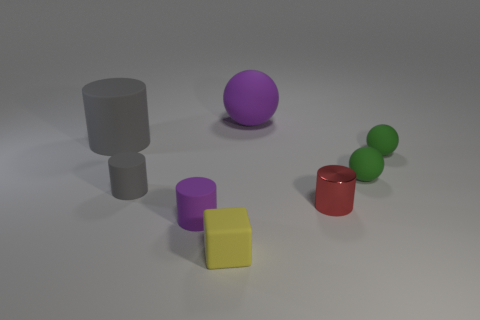Subtract all green spheres. How many were subtracted if there are1green spheres left? 1 Add 1 big blue rubber blocks. How many objects exist? 9 Subtract all cubes. How many objects are left? 7 Subtract 0 brown cubes. How many objects are left? 8 Subtract all yellow metallic balls. Subtract all tiny green matte objects. How many objects are left? 6 Add 8 small purple cylinders. How many small purple cylinders are left? 9 Add 6 red shiny things. How many red shiny things exist? 7 